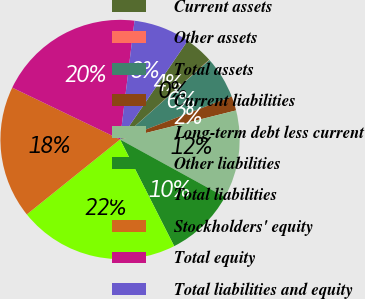Convert chart to OTSL. <chart><loc_0><loc_0><loc_500><loc_500><pie_chart><fcel>Current assets<fcel>Other assets<fcel>Total assets<fcel>Current liabilities<fcel>Long-term debt less current<fcel>Other liabilities<fcel>Total liabilities<fcel>Stockholders' equity<fcel>Total equity<fcel>Total liabilities and equity<nl><fcel>3.83%<fcel>0.04%<fcel>5.73%<fcel>1.94%<fcel>11.9%<fcel>9.53%<fcel>21.7%<fcel>17.91%<fcel>19.8%<fcel>7.63%<nl></chart> 